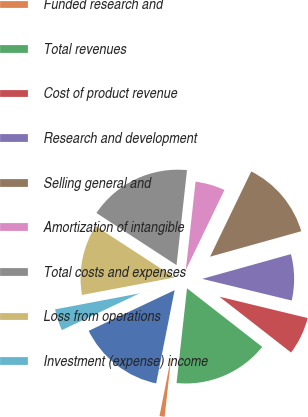Convert chart. <chart><loc_0><loc_0><loc_500><loc_500><pie_chart><fcel>Product<fcel>Funded research and<fcel>Total revenues<fcel>Cost of product revenue<fcel>Research and development<fcel>Selling general and<fcel>Amortization of intangible<fcel>Total costs and expenses<fcel>Loss from operations<fcel>Investment (expense) income<nl><fcel>14.86%<fcel>1.36%<fcel>16.21%<fcel>6.76%<fcel>8.11%<fcel>13.51%<fcel>5.41%<fcel>17.56%<fcel>12.16%<fcel>4.06%<nl></chart> 